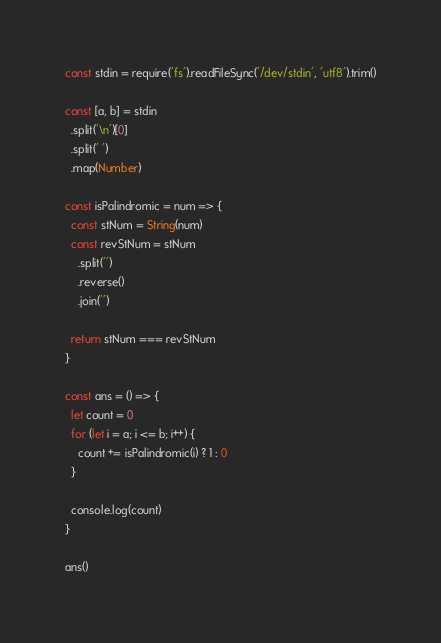<code> <loc_0><loc_0><loc_500><loc_500><_TypeScript_>const stdin = require('fs').readFileSync('/dev/stdin', 'utf8').trim()

const [a, b] = stdin
  .split('\n')[0]
  .split(' ')
  .map(Number)

const isPalindromic = num => {
  const stNum = String(num)
  const revStNum = stNum
    .split('')
    .reverse()
    .join('')

  return stNum === revStNum
}

const ans = () => {
  let count = 0
  for (let i = a; i <= b; i++) {
    count += isPalindromic(i) ? 1 : 0
  }

  console.log(count)
}

ans()
</code> 